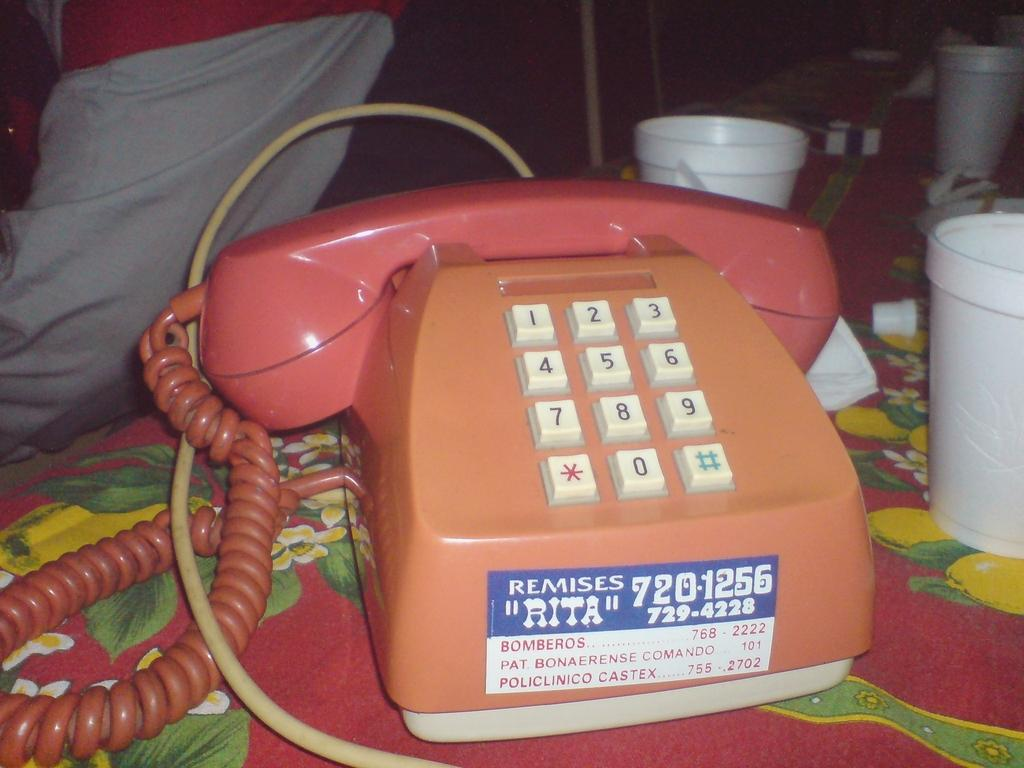What object is on the table in the image? There is a telephone on a table in the image. What else can be seen in the image besides the telephone? There are boxes visible in the image. Can you describe the person in the image? It appears that there is a person standing on the left side of the image. What breed of dog is sitting next to the person in the image? There is no dog present in the image; only a person and various objects are visible. 